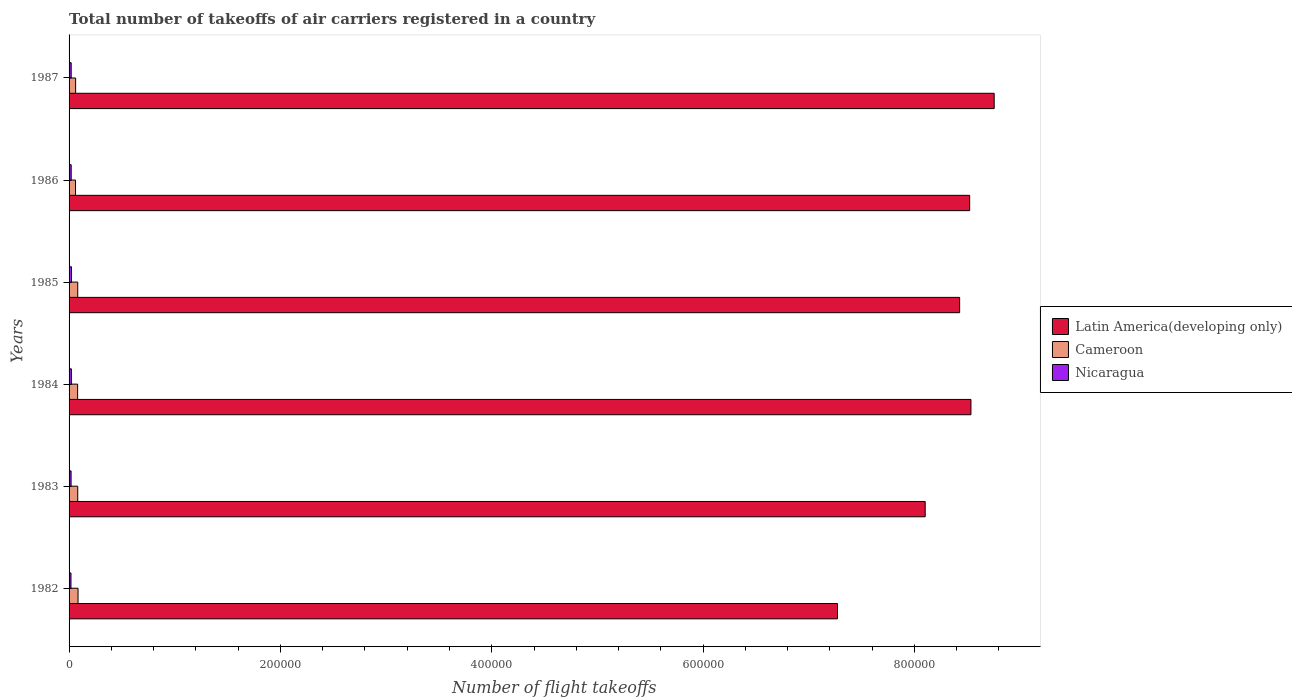How many different coloured bars are there?
Keep it short and to the point. 3. How many bars are there on the 2nd tick from the top?
Make the answer very short. 3. What is the total number of flight takeoffs in Nicaragua in 1987?
Provide a succinct answer. 2000. Across all years, what is the maximum total number of flight takeoffs in Nicaragua?
Keep it short and to the point. 2300. Across all years, what is the minimum total number of flight takeoffs in Latin America(developing only)?
Offer a terse response. 7.27e+05. What is the total total number of flight takeoffs in Nicaragua in the graph?
Offer a terse response. 1.22e+04. What is the difference between the total number of flight takeoffs in Nicaragua in 1982 and that in 1987?
Offer a very short reply. -200. What is the difference between the total number of flight takeoffs in Latin America(developing only) in 1986 and the total number of flight takeoffs in Nicaragua in 1982?
Make the answer very short. 8.50e+05. What is the average total number of flight takeoffs in Latin America(developing only) per year?
Ensure brevity in your answer.  8.27e+05. In the year 1983, what is the difference between the total number of flight takeoffs in Cameroon and total number of flight takeoffs in Latin America(developing only)?
Offer a very short reply. -8.02e+05. What is the ratio of the total number of flight takeoffs in Cameroon in 1983 to that in 1984?
Your answer should be very brief. 1.01. What is the difference between the highest and the second highest total number of flight takeoffs in Cameroon?
Provide a succinct answer. 300. What does the 3rd bar from the top in 1983 represents?
Ensure brevity in your answer.  Latin America(developing only). What does the 2nd bar from the bottom in 1984 represents?
Ensure brevity in your answer.  Cameroon. Is it the case that in every year, the sum of the total number of flight takeoffs in Nicaragua and total number of flight takeoffs in Cameroon is greater than the total number of flight takeoffs in Latin America(developing only)?
Offer a terse response. No. What is the difference between two consecutive major ticks on the X-axis?
Make the answer very short. 2.00e+05. How many legend labels are there?
Offer a very short reply. 3. How are the legend labels stacked?
Your response must be concise. Vertical. What is the title of the graph?
Ensure brevity in your answer.  Total number of takeoffs of air carriers registered in a country. What is the label or title of the X-axis?
Make the answer very short. Number of flight takeoffs. What is the label or title of the Y-axis?
Offer a terse response. Years. What is the Number of flight takeoffs in Latin America(developing only) in 1982?
Offer a terse response. 7.27e+05. What is the Number of flight takeoffs of Cameroon in 1982?
Offer a very short reply. 8500. What is the Number of flight takeoffs of Nicaragua in 1982?
Make the answer very short. 1800. What is the Number of flight takeoffs of Latin America(developing only) in 1983?
Your answer should be compact. 8.10e+05. What is the Number of flight takeoffs of Cameroon in 1983?
Your response must be concise. 8200. What is the Number of flight takeoffs in Nicaragua in 1983?
Your response must be concise. 1900. What is the Number of flight takeoffs in Latin America(developing only) in 1984?
Make the answer very short. 8.54e+05. What is the Number of flight takeoffs of Cameroon in 1984?
Your response must be concise. 8100. What is the Number of flight takeoffs in Nicaragua in 1984?
Make the answer very short. 2200. What is the Number of flight takeoffs of Latin America(developing only) in 1985?
Your answer should be very brief. 8.43e+05. What is the Number of flight takeoffs in Cameroon in 1985?
Make the answer very short. 8200. What is the Number of flight takeoffs of Nicaragua in 1985?
Offer a terse response. 2300. What is the Number of flight takeoffs of Latin America(developing only) in 1986?
Keep it short and to the point. 8.52e+05. What is the Number of flight takeoffs of Cameroon in 1986?
Make the answer very short. 6100. What is the Number of flight takeoffs of Latin America(developing only) in 1987?
Your answer should be very brief. 8.76e+05. What is the Number of flight takeoffs in Cameroon in 1987?
Provide a succinct answer. 6200. Across all years, what is the maximum Number of flight takeoffs of Latin America(developing only)?
Offer a terse response. 8.76e+05. Across all years, what is the maximum Number of flight takeoffs in Cameroon?
Ensure brevity in your answer.  8500. Across all years, what is the maximum Number of flight takeoffs in Nicaragua?
Your answer should be very brief. 2300. Across all years, what is the minimum Number of flight takeoffs in Latin America(developing only)?
Keep it short and to the point. 7.27e+05. Across all years, what is the minimum Number of flight takeoffs of Cameroon?
Ensure brevity in your answer.  6100. Across all years, what is the minimum Number of flight takeoffs in Nicaragua?
Ensure brevity in your answer.  1800. What is the total Number of flight takeoffs in Latin America(developing only) in the graph?
Make the answer very short. 4.96e+06. What is the total Number of flight takeoffs in Cameroon in the graph?
Ensure brevity in your answer.  4.53e+04. What is the total Number of flight takeoffs in Nicaragua in the graph?
Give a very brief answer. 1.22e+04. What is the difference between the Number of flight takeoffs in Latin America(developing only) in 1982 and that in 1983?
Offer a very short reply. -8.30e+04. What is the difference between the Number of flight takeoffs in Cameroon in 1982 and that in 1983?
Keep it short and to the point. 300. What is the difference between the Number of flight takeoffs of Nicaragua in 1982 and that in 1983?
Offer a terse response. -100. What is the difference between the Number of flight takeoffs of Latin America(developing only) in 1982 and that in 1984?
Keep it short and to the point. -1.26e+05. What is the difference between the Number of flight takeoffs of Nicaragua in 1982 and that in 1984?
Your answer should be compact. -400. What is the difference between the Number of flight takeoffs in Latin America(developing only) in 1982 and that in 1985?
Give a very brief answer. -1.16e+05. What is the difference between the Number of flight takeoffs in Cameroon in 1982 and that in 1985?
Offer a very short reply. 300. What is the difference between the Number of flight takeoffs of Nicaragua in 1982 and that in 1985?
Give a very brief answer. -500. What is the difference between the Number of flight takeoffs of Latin America(developing only) in 1982 and that in 1986?
Your answer should be very brief. -1.25e+05. What is the difference between the Number of flight takeoffs of Cameroon in 1982 and that in 1986?
Provide a succinct answer. 2400. What is the difference between the Number of flight takeoffs in Nicaragua in 1982 and that in 1986?
Your answer should be very brief. -200. What is the difference between the Number of flight takeoffs of Latin America(developing only) in 1982 and that in 1987?
Provide a succinct answer. -1.48e+05. What is the difference between the Number of flight takeoffs in Cameroon in 1982 and that in 1987?
Offer a terse response. 2300. What is the difference between the Number of flight takeoffs of Nicaragua in 1982 and that in 1987?
Provide a succinct answer. -200. What is the difference between the Number of flight takeoffs in Latin America(developing only) in 1983 and that in 1984?
Your answer should be compact. -4.33e+04. What is the difference between the Number of flight takeoffs in Nicaragua in 1983 and that in 1984?
Provide a short and direct response. -300. What is the difference between the Number of flight takeoffs of Latin America(developing only) in 1983 and that in 1985?
Give a very brief answer. -3.26e+04. What is the difference between the Number of flight takeoffs of Nicaragua in 1983 and that in 1985?
Ensure brevity in your answer.  -400. What is the difference between the Number of flight takeoffs of Latin America(developing only) in 1983 and that in 1986?
Your response must be concise. -4.21e+04. What is the difference between the Number of flight takeoffs of Cameroon in 1983 and that in 1986?
Provide a short and direct response. 2100. What is the difference between the Number of flight takeoffs of Nicaragua in 1983 and that in 1986?
Provide a short and direct response. -100. What is the difference between the Number of flight takeoffs in Latin America(developing only) in 1983 and that in 1987?
Ensure brevity in your answer.  -6.53e+04. What is the difference between the Number of flight takeoffs of Nicaragua in 1983 and that in 1987?
Make the answer very short. -100. What is the difference between the Number of flight takeoffs of Latin America(developing only) in 1984 and that in 1985?
Your answer should be compact. 1.07e+04. What is the difference between the Number of flight takeoffs of Cameroon in 1984 and that in 1985?
Provide a succinct answer. -100. What is the difference between the Number of flight takeoffs in Nicaragua in 1984 and that in 1985?
Your answer should be compact. -100. What is the difference between the Number of flight takeoffs in Latin America(developing only) in 1984 and that in 1986?
Offer a very short reply. 1200. What is the difference between the Number of flight takeoffs of Nicaragua in 1984 and that in 1986?
Offer a very short reply. 200. What is the difference between the Number of flight takeoffs of Latin America(developing only) in 1984 and that in 1987?
Keep it short and to the point. -2.20e+04. What is the difference between the Number of flight takeoffs in Cameroon in 1984 and that in 1987?
Your response must be concise. 1900. What is the difference between the Number of flight takeoffs in Latin America(developing only) in 1985 and that in 1986?
Your answer should be very brief. -9500. What is the difference between the Number of flight takeoffs in Cameroon in 1985 and that in 1986?
Offer a terse response. 2100. What is the difference between the Number of flight takeoffs of Nicaragua in 1985 and that in 1986?
Provide a short and direct response. 300. What is the difference between the Number of flight takeoffs in Latin America(developing only) in 1985 and that in 1987?
Give a very brief answer. -3.27e+04. What is the difference between the Number of flight takeoffs in Nicaragua in 1985 and that in 1987?
Ensure brevity in your answer.  300. What is the difference between the Number of flight takeoffs in Latin America(developing only) in 1986 and that in 1987?
Give a very brief answer. -2.32e+04. What is the difference between the Number of flight takeoffs of Cameroon in 1986 and that in 1987?
Make the answer very short. -100. What is the difference between the Number of flight takeoffs in Latin America(developing only) in 1982 and the Number of flight takeoffs in Cameroon in 1983?
Provide a short and direct response. 7.19e+05. What is the difference between the Number of flight takeoffs in Latin America(developing only) in 1982 and the Number of flight takeoffs in Nicaragua in 1983?
Your answer should be compact. 7.25e+05. What is the difference between the Number of flight takeoffs of Cameroon in 1982 and the Number of flight takeoffs of Nicaragua in 1983?
Offer a very short reply. 6600. What is the difference between the Number of flight takeoffs in Latin America(developing only) in 1982 and the Number of flight takeoffs in Cameroon in 1984?
Offer a terse response. 7.19e+05. What is the difference between the Number of flight takeoffs of Latin America(developing only) in 1982 and the Number of flight takeoffs of Nicaragua in 1984?
Make the answer very short. 7.25e+05. What is the difference between the Number of flight takeoffs of Cameroon in 1982 and the Number of flight takeoffs of Nicaragua in 1984?
Give a very brief answer. 6300. What is the difference between the Number of flight takeoffs of Latin America(developing only) in 1982 and the Number of flight takeoffs of Cameroon in 1985?
Provide a succinct answer. 7.19e+05. What is the difference between the Number of flight takeoffs of Latin America(developing only) in 1982 and the Number of flight takeoffs of Nicaragua in 1985?
Make the answer very short. 7.25e+05. What is the difference between the Number of flight takeoffs of Cameroon in 1982 and the Number of flight takeoffs of Nicaragua in 1985?
Make the answer very short. 6200. What is the difference between the Number of flight takeoffs of Latin America(developing only) in 1982 and the Number of flight takeoffs of Cameroon in 1986?
Your response must be concise. 7.21e+05. What is the difference between the Number of flight takeoffs of Latin America(developing only) in 1982 and the Number of flight takeoffs of Nicaragua in 1986?
Give a very brief answer. 7.25e+05. What is the difference between the Number of flight takeoffs of Cameroon in 1982 and the Number of flight takeoffs of Nicaragua in 1986?
Your response must be concise. 6500. What is the difference between the Number of flight takeoffs in Latin America(developing only) in 1982 and the Number of flight takeoffs in Cameroon in 1987?
Your answer should be compact. 7.21e+05. What is the difference between the Number of flight takeoffs in Latin America(developing only) in 1982 and the Number of flight takeoffs in Nicaragua in 1987?
Your answer should be very brief. 7.25e+05. What is the difference between the Number of flight takeoffs in Cameroon in 1982 and the Number of flight takeoffs in Nicaragua in 1987?
Provide a succinct answer. 6500. What is the difference between the Number of flight takeoffs of Latin America(developing only) in 1983 and the Number of flight takeoffs of Cameroon in 1984?
Offer a terse response. 8.02e+05. What is the difference between the Number of flight takeoffs in Latin America(developing only) in 1983 and the Number of flight takeoffs in Nicaragua in 1984?
Offer a very short reply. 8.08e+05. What is the difference between the Number of flight takeoffs of Cameroon in 1983 and the Number of flight takeoffs of Nicaragua in 1984?
Give a very brief answer. 6000. What is the difference between the Number of flight takeoffs in Latin America(developing only) in 1983 and the Number of flight takeoffs in Cameroon in 1985?
Provide a short and direct response. 8.02e+05. What is the difference between the Number of flight takeoffs of Latin America(developing only) in 1983 and the Number of flight takeoffs of Nicaragua in 1985?
Make the answer very short. 8.08e+05. What is the difference between the Number of flight takeoffs of Cameroon in 1983 and the Number of flight takeoffs of Nicaragua in 1985?
Your response must be concise. 5900. What is the difference between the Number of flight takeoffs in Latin America(developing only) in 1983 and the Number of flight takeoffs in Cameroon in 1986?
Keep it short and to the point. 8.04e+05. What is the difference between the Number of flight takeoffs in Latin America(developing only) in 1983 and the Number of flight takeoffs in Nicaragua in 1986?
Offer a very short reply. 8.08e+05. What is the difference between the Number of flight takeoffs of Cameroon in 1983 and the Number of flight takeoffs of Nicaragua in 1986?
Your answer should be very brief. 6200. What is the difference between the Number of flight takeoffs in Latin America(developing only) in 1983 and the Number of flight takeoffs in Cameroon in 1987?
Make the answer very short. 8.04e+05. What is the difference between the Number of flight takeoffs of Latin America(developing only) in 1983 and the Number of flight takeoffs of Nicaragua in 1987?
Offer a very short reply. 8.08e+05. What is the difference between the Number of flight takeoffs in Cameroon in 1983 and the Number of flight takeoffs in Nicaragua in 1987?
Your answer should be compact. 6200. What is the difference between the Number of flight takeoffs in Latin America(developing only) in 1984 and the Number of flight takeoffs in Cameroon in 1985?
Provide a short and direct response. 8.45e+05. What is the difference between the Number of flight takeoffs in Latin America(developing only) in 1984 and the Number of flight takeoffs in Nicaragua in 1985?
Your answer should be very brief. 8.51e+05. What is the difference between the Number of flight takeoffs of Cameroon in 1984 and the Number of flight takeoffs of Nicaragua in 1985?
Make the answer very short. 5800. What is the difference between the Number of flight takeoffs in Latin America(developing only) in 1984 and the Number of flight takeoffs in Cameroon in 1986?
Offer a very short reply. 8.47e+05. What is the difference between the Number of flight takeoffs of Latin America(developing only) in 1984 and the Number of flight takeoffs of Nicaragua in 1986?
Keep it short and to the point. 8.52e+05. What is the difference between the Number of flight takeoffs of Cameroon in 1984 and the Number of flight takeoffs of Nicaragua in 1986?
Ensure brevity in your answer.  6100. What is the difference between the Number of flight takeoffs in Latin America(developing only) in 1984 and the Number of flight takeoffs in Cameroon in 1987?
Provide a succinct answer. 8.47e+05. What is the difference between the Number of flight takeoffs in Latin America(developing only) in 1984 and the Number of flight takeoffs in Nicaragua in 1987?
Offer a very short reply. 8.52e+05. What is the difference between the Number of flight takeoffs of Cameroon in 1984 and the Number of flight takeoffs of Nicaragua in 1987?
Your response must be concise. 6100. What is the difference between the Number of flight takeoffs in Latin America(developing only) in 1985 and the Number of flight takeoffs in Cameroon in 1986?
Offer a very short reply. 8.37e+05. What is the difference between the Number of flight takeoffs in Latin America(developing only) in 1985 and the Number of flight takeoffs in Nicaragua in 1986?
Make the answer very short. 8.41e+05. What is the difference between the Number of flight takeoffs in Cameroon in 1985 and the Number of flight takeoffs in Nicaragua in 1986?
Ensure brevity in your answer.  6200. What is the difference between the Number of flight takeoffs of Latin America(developing only) in 1985 and the Number of flight takeoffs of Cameroon in 1987?
Provide a short and direct response. 8.37e+05. What is the difference between the Number of flight takeoffs of Latin America(developing only) in 1985 and the Number of flight takeoffs of Nicaragua in 1987?
Make the answer very short. 8.41e+05. What is the difference between the Number of flight takeoffs of Cameroon in 1985 and the Number of flight takeoffs of Nicaragua in 1987?
Your answer should be very brief. 6200. What is the difference between the Number of flight takeoffs in Latin America(developing only) in 1986 and the Number of flight takeoffs in Cameroon in 1987?
Make the answer very short. 8.46e+05. What is the difference between the Number of flight takeoffs in Latin America(developing only) in 1986 and the Number of flight takeoffs in Nicaragua in 1987?
Offer a very short reply. 8.50e+05. What is the difference between the Number of flight takeoffs in Cameroon in 1986 and the Number of flight takeoffs in Nicaragua in 1987?
Give a very brief answer. 4100. What is the average Number of flight takeoffs of Latin America(developing only) per year?
Provide a succinct answer. 8.27e+05. What is the average Number of flight takeoffs of Cameroon per year?
Your response must be concise. 7550. What is the average Number of flight takeoffs of Nicaragua per year?
Offer a very short reply. 2033.33. In the year 1982, what is the difference between the Number of flight takeoffs of Latin America(developing only) and Number of flight takeoffs of Cameroon?
Provide a succinct answer. 7.19e+05. In the year 1982, what is the difference between the Number of flight takeoffs of Latin America(developing only) and Number of flight takeoffs of Nicaragua?
Your answer should be compact. 7.25e+05. In the year 1982, what is the difference between the Number of flight takeoffs of Cameroon and Number of flight takeoffs of Nicaragua?
Give a very brief answer. 6700. In the year 1983, what is the difference between the Number of flight takeoffs of Latin America(developing only) and Number of flight takeoffs of Cameroon?
Your answer should be compact. 8.02e+05. In the year 1983, what is the difference between the Number of flight takeoffs of Latin America(developing only) and Number of flight takeoffs of Nicaragua?
Keep it short and to the point. 8.08e+05. In the year 1983, what is the difference between the Number of flight takeoffs of Cameroon and Number of flight takeoffs of Nicaragua?
Give a very brief answer. 6300. In the year 1984, what is the difference between the Number of flight takeoffs of Latin America(developing only) and Number of flight takeoffs of Cameroon?
Provide a short and direct response. 8.45e+05. In the year 1984, what is the difference between the Number of flight takeoffs in Latin America(developing only) and Number of flight takeoffs in Nicaragua?
Keep it short and to the point. 8.51e+05. In the year 1984, what is the difference between the Number of flight takeoffs in Cameroon and Number of flight takeoffs in Nicaragua?
Provide a short and direct response. 5900. In the year 1985, what is the difference between the Number of flight takeoffs in Latin America(developing only) and Number of flight takeoffs in Cameroon?
Give a very brief answer. 8.35e+05. In the year 1985, what is the difference between the Number of flight takeoffs in Latin America(developing only) and Number of flight takeoffs in Nicaragua?
Your answer should be very brief. 8.40e+05. In the year 1985, what is the difference between the Number of flight takeoffs of Cameroon and Number of flight takeoffs of Nicaragua?
Offer a very short reply. 5900. In the year 1986, what is the difference between the Number of flight takeoffs in Latin America(developing only) and Number of flight takeoffs in Cameroon?
Provide a succinct answer. 8.46e+05. In the year 1986, what is the difference between the Number of flight takeoffs in Latin America(developing only) and Number of flight takeoffs in Nicaragua?
Offer a terse response. 8.50e+05. In the year 1986, what is the difference between the Number of flight takeoffs of Cameroon and Number of flight takeoffs of Nicaragua?
Keep it short and to the point. 4100. In the year 1987, what is the difference between the Number of flight takeoffs in Latin America(developing only) and Number of flight takeoffs in Cameroon?
Make the answer very short. 8.69e+05. In the year 1987, what is the difference between the Number of flight takeoffs in Latin America(developing only) and Number of flight takeoffs in Nicaragua?
Offer a terse response. 8.74e+05. In the year 1987, what is the difference between the Number of flight takeoffs in Cameroon and Number of flight takeoffs in Nicaragua?
Provide a short and direct response. 4200. What is the ratio of the Number of flight takeoffs of Latin America(developing only) in 1982 to that in 1983?
Offer a terse response. 0.9. What is the ratio of the Number of flight takeoffs in Cameroon in 1982 to that in 1983?
Your response must be concise. 1.04. What is the ratio of the Number of flight takeoffs in Latin America(developing only) in 1982 to that in 1984?
Offer a very short reply. 0.85. What is the ratio of the Number of flight takeoffs of Cameroon in 1982 to that in 1984?
Your answer should be very brief. 1.05. What is the ratio of the Number of flight takeoffs in Nicaragua in 1982 to that in 1984?
Provide a short and direct response. 0.82. What is the ratio of the Number of flight takeoffs of Latin America(developing only) in 1982 to that in 1985?
Offer a terse response. 0.86. What is the ratio of the Number of flight takeoffs in Cameroon in 1982 to that in 1985?
Offer a very short reply. 1.04. What is the ratio of the Number of flight takeoffs of Nicaragua in 1982 to that in 1985?
Your answer should be compact. 0.78. What is the ratio of the Number of flight takeoffs of Latin America(developing only) in 1982 to that in 1986?
Keep it short and to the point. 0.85. What is the ratio of the Number of flight takeoffs of Cameroon in 1982 to that in 1986?
Make the answer very short. 1.39. What is the ratio of the Number of flight takeoffs in Latin America(developing only) in 1982 to that in 1987?
Offer a terse response. 0.83. What is the ratio of the Number of flight takeoffs in Cameroon in 1982 to that in 1987?
Ensure brevity in your answer.  1.37. What is the ratio of the Number of flight takeoffs in Latin America(developing only) in 1983 to that in 1984?
Your answer should be compact. 0.95. What is the ratio of the Number of flight takeoffs of Cameroon in 1983 to that in 1984?
Provide a succinct answer. 1.01. What is the ratio of the Number of flight takeoffs in Nicaragua in 1983 to that in 1984?
Provide a short and direct response. 0.86. What is the ratio of the Number of flight takeoffs of Latin America(developing only) in 1983 to that in 1985?
Make the answer very short. 0.96. What is the ratio of the Number of flight takeoffs in Nicaragua in 1983 to that in 1985?
Offer a terse response. 0.83. What is the ratio of the Number of flight takeoffs of Latin America(developing only) in 1983 to that in 1986?
Your answer should be compact. 0.95. What is the ratio of the Number of flight takeoffs in Cameroon in 1983 to that in 1986?
Your answer should be compact. 1.34. What is the ratio of the Number of flight takeoffs in Nicaragua in 1983 to that in 1986?
Ensure brevity in your answer.  0.95. What is the ratio of the Number of flight takeoffs in Latin America(developing only) in 1983 to that in 1987?
Your answer should be compact. 0.93. What is the ratio of the Number of flight takeoffs of Cameroon in 1983 to that in 1987?
Make the answer very short. 1.32. What is the ratio of the Number of flight takeoffs in Latin America(developing only) in 1984 to that in 1985?
Your answer should be compact. 1.01. What is the ratio of the Number of flight takeoffs in Cameroon in 1984 to that in 1985?
Give a very brief answer. 0.99. What is the ratio of the Number of flight takeoffs of Nicaragua in 1984 to that in 1985?
Make the answer very short. 0.96. What is the ratio of the Number of flight takeoffs in Cameroon in 1984 to that in 1986?
Your answer should be very brief. 1.33. What is the ratio of the Number of flight takeoffs of Nicaragua in 1984 to that in 1986?
Your answer should be compact. 1.1. What is the ratio of the Number of flight takeoffs in Latin America(developing only) in 1984 to that in 1987?
Your answer should be compact. 0.97. What is the ratio of the Number of flight takeoffs in Cameroon in 1984 to that in 1987?
Your response must be concise. 1.31. What is the ratio of the Number of flight takeoffs of Latin America(developing only) in 1985 to that in 1986?
Ensure brevity in your answer.  0.99. What is the ratio of the Number of flight takeoffs in Cameroon in 1985 to that in 1986?
Offer a very short reply. 1.34. What is the ratio of the Number of flight takeoffs of Nicaragua in 1985 to that in 1986?
Your response must be concise. 1.15. What is the ratio of the Number of flight takeoffs of Latin America(developing only) in 1985 to that in 1987?
Offer a very short reply. 0.96. What is the ratio of the Number of flight takeoffs of Cameroon in 1985 to that in 1987?
Provide a short and direct response. 1.32. What is the ratio of the Number of flight takeoffs in Nicaragua in 1985 to that in 1987?
Your answer should be very brief. 1.15. What is the ratio of the Number of flight takeoffs in Latin America(developing only) in 1986 to that in 1987?
Your answer should be very brief. 0.97. What is the ratio of the Number of flight takeoffs in Cameroon in 1986 to that in 1987?
Offer a terse response. 0.98. What is the ratio of the Number of flight takeoffs of Nicaragua in 1986 to that in 1987?
Your response must be concise. 1. What is the difference between the highest and the second highest Number of flight takeoffs in Latin America(developing only)?
Offer a terse response. 2.20e+04. What is the difference between the highest and the second highest Number of flight takeoffs of Cameroon?
Provide a short and direct response. 300. What is the difference between the highest and the lowest Number of flight takeoffs of Latin America(developing only)?
Your response must be concise. 1.48e+05. What is the difference between the highest and the lowest Number of flight takeoffs in Cameroon?
Offer a terse response. 2400. 